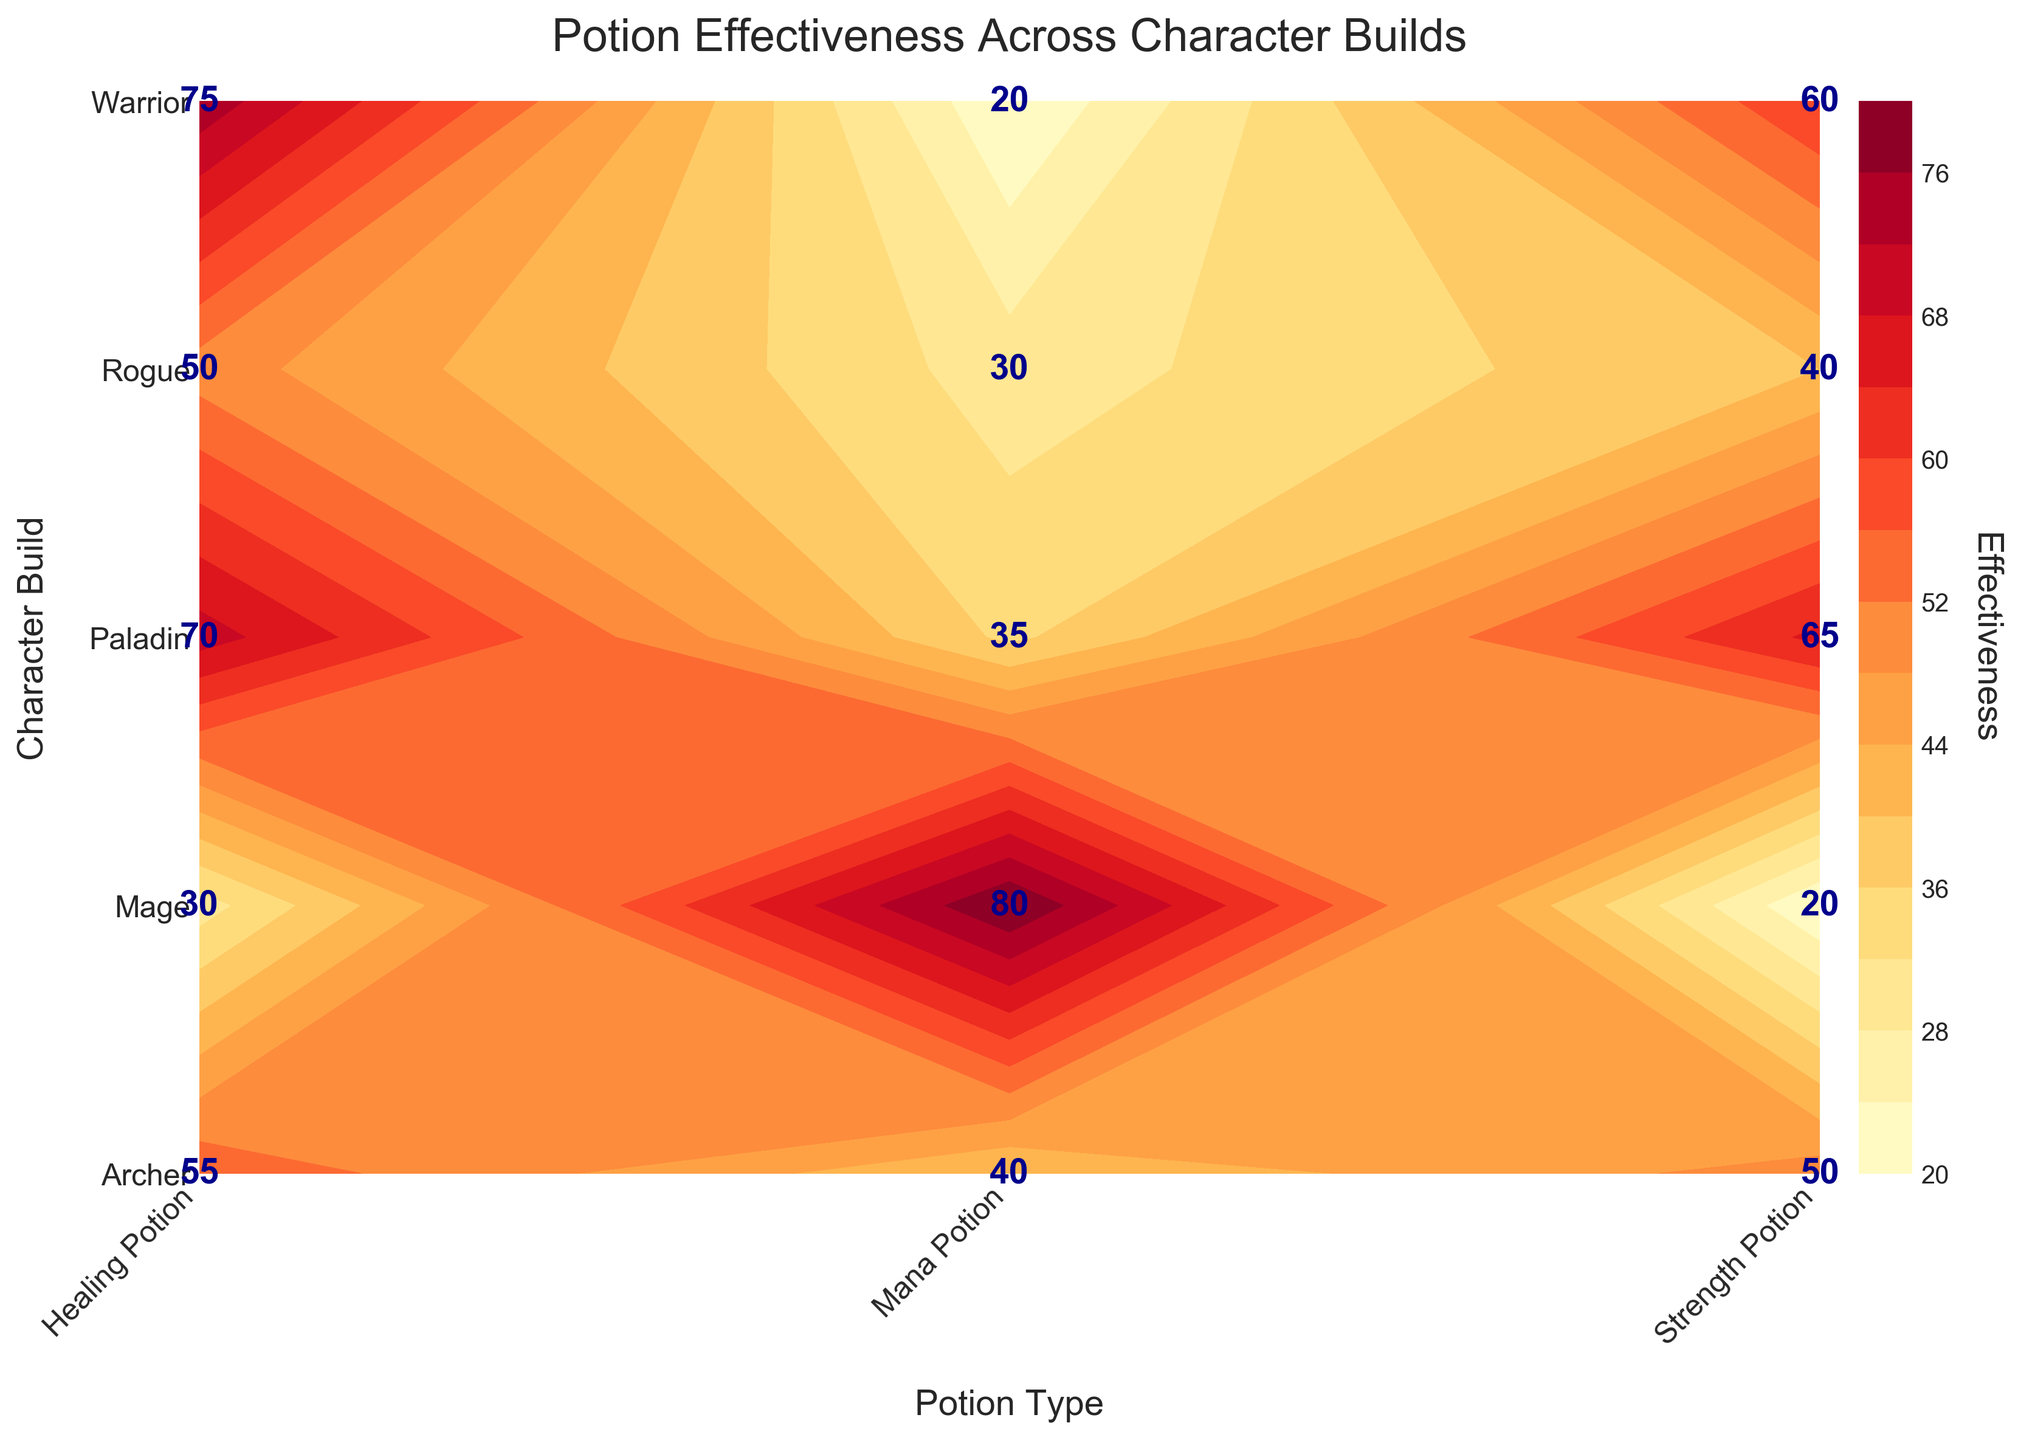What's the title of the figure? The title of the figure is displayed at the top of the plot. It helps to understand the main topic or content of the visualization. The title reads "Potion Effectiveness Across Character Builds."
Answer: Potion Effectiveness Across Character Builds Which potion type has the highest effectiveness for the Mage character build? To find the highest effectiveness for the Mage character build, look at the rows corresponding to Mage and identify the highest numerical label among the columns. The highest effectiveness value is 80 for Mana Potion.
Answer: Mana Potion Which character build has the lowest effectiveness for Strength Potion? Look for the lowest numerical value in the Strength Potion column across all character builds. The lowest effectiveness for Strength Potion is 20 for the Mage character build.
Answer: Mage What is the average effectiveness of Healing Potions across all character builds? To find the average effectiveness, add the effectiveness values for Healing Potions across all character builds and then divide by the number of character builds. The values are 75, 50, 30, 55, and 70, summing to 280. There are 5 character builds, so 280/5 = 56.
Answer: 56 Which character build shows the most balanced effectiveness across the three potion types? A balanced effectiveness would have relatively similar values across different potion types. Comparing the spreads for each character build, the Paladin has values 70, 35, and 65, which are more evenly spread compared to others.
Answer: Paladin What is the difference in effectiveness between the Healing Potion and Strength Potion for the Warrior build? Find the effectiveness values for Healing Potion and Strength Potion for the Warrior build. The values are 75 (Healing) and 60 (Strength). The difference is 75 - 60 = 15.
Answer: 15 Which potion type generally has the highest average effectiveness across all character builds? Calculate the average effectiveness for each potion type across all character builds by summing their effectiveness values and dividing by the number of character builds. Healing Potion: (75 + 50 + 30 + 55 + 70)/5 = 56; Mana Potion: (20 + 30 + 80 + 40 + 35)/5 = 41; Strength Potion: (60 + 40 + 20 + 50 + 65)/5 = 47. The highest average is for Healing Potion with 56.
Answer: Healing Potion Across which character builds do Healing Potion effectiveness values decrease? Check the effectiveness values of Healing Potions in decreasing order across character builds. The sequence does not strictly decrease for any pairs, although there are variations and some decrease (e.g., comparing Warrior, Rogue, Mage, Archer, Paladin).
Answer: None How many unique levels of effectiveness are displayed in the contour plot? Examine the labels on the contour plot. Counting all unique labels gives us 12 levels (75, 20, 60, 50, 30, 40, 80, 55, 70, 35, 65).
Answer: 12 What is the contour color representing the highest effectiveness level? Refer to the color bar on the plot. The highest effectiveness level (80) correlates with the darkest shade of color used within the 'YlOrRd' colormap, typically a rich red or dark orange.
Answer: Dark red or orange 